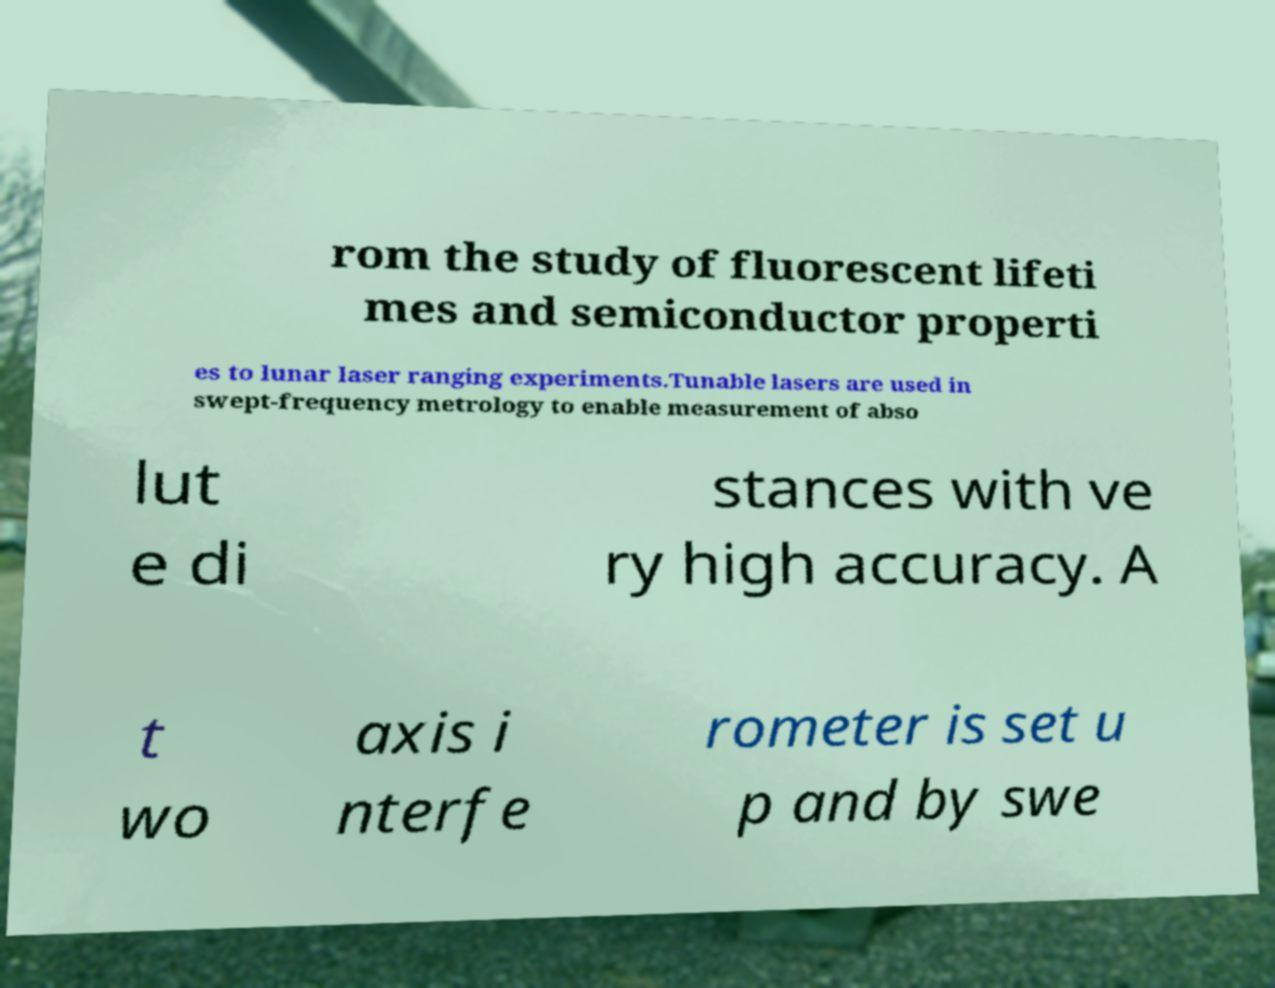For documentation purposes, I need the text within this image transcribed. Could you provide that? rom the study of fluorescent lifeti mes and semiconductor properti es to lunar laser ranging experiments.Tunable lasers are used in swept-frequency metrology to enable measurement of abso lut e di stances with ve ry high accuracy. A t wo axis i nterfe rometer is set u p and by swe 